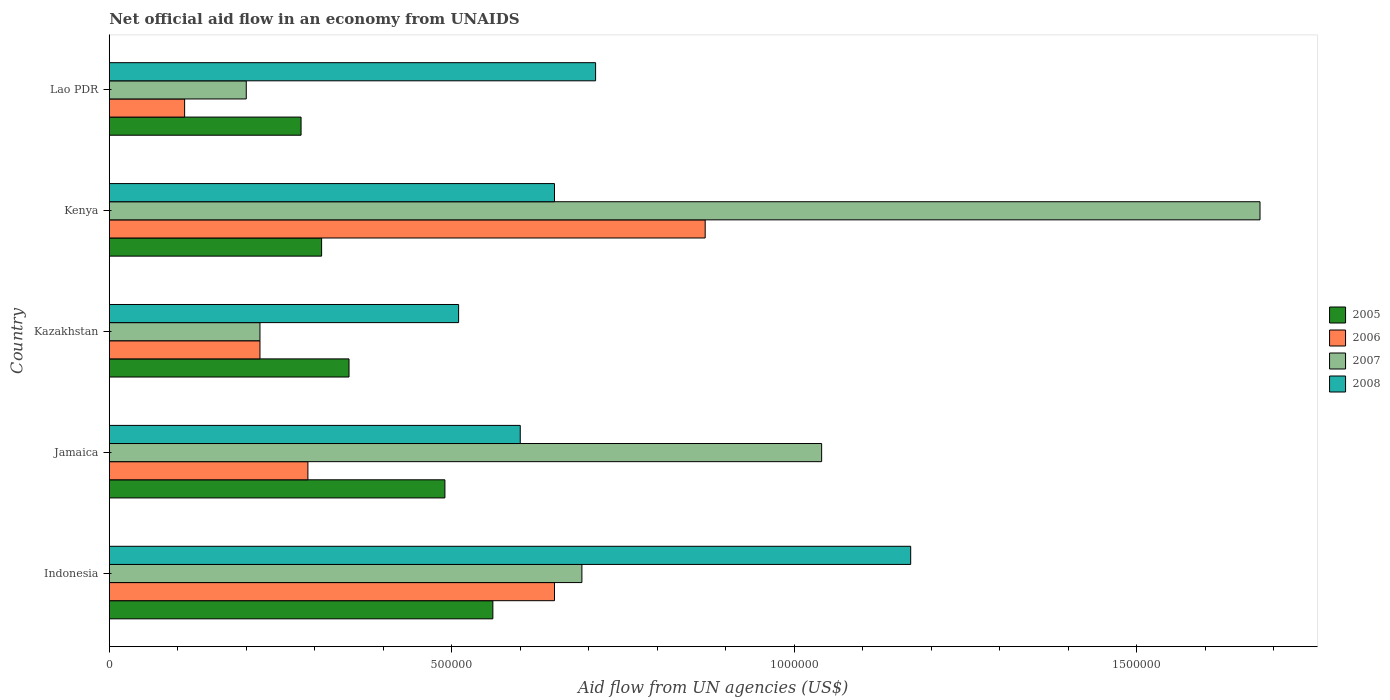How many different coloured bars are there?
Keep it short and to the point. 4. How many groups of bars are there?
Your answer should be very brief. 5. Are the number of bars per tick equal to the number of legend labels?
Provide a succinct answer. Yes. Are the number of bars on each tick of the Y-axis equal?
Offer a very short reply. Yes. How many bars are there on the 2nd tick from the top?
Give a very brief answer. 4. How many bars are there on the 4th tick from the bottom?
Give a very brief answer. 4. What is the label of the 2nd group of bars from the top?
Your answer should be very brief. Kenya. Across all countries, what is the maximum net official aid flow in 2008?
Offer a very short reply. 1.17e+06. In which country was the net official aid flow in 2006 maximum?
Provide a succinct answer. Kenya. In which country was the net official aid flow in 2007 minimum?
Offer a terse response. Lao PDR. What is the total net official aid flow in 2005 in the graph?
Your answer should be compact. 1.99e+06. What is the difference between the net official aid flow in 2006 in Indonesia and that in Jamaica?
Your answer should be very brief. 3.60e+05. What is the difference between the net official aid flow in 2008 in Lao PDR and the net official aid flow in 2006 in Kazakhstan?
Your answer should be compact. 4.90e+05. What is the average net official aid flow in 2006 per country?
Make the answer very short. 4.28e+05. What is the difference between the net official aid flow in 2007 and net official aid flow in 2008 in Kenya?
Offer a terse response. 1.03e+06. In how many countries, is the net official aid flow in 2005 greater than 1200000 US$?
Offer a very short reply. 0. What is the ratio of the net official aid flow in 2008 in Jamaica to that in Kenya?
Your answer should be very brief. 0.92. Is the net official aid flow in 2005 in Indonesia less than that in Kenya?
Your response must be concise. No. What is the difference between the highest and the second highest net official aid flow in 2008?
Make the answer very short. 4.60e+05. Is the sum of the net official aid flow in 2007 in Jamaica and Kenya greater than the maximum net official aid flow in 2005 across all countries?
Provide a succinct answer. Yes. How many bars are there?
Your answer should be compact. 20. How many countries are there in the graph?
Keep it short and to the point. 5. What is the difference between two consecutive major ticks on the X-axis?
Offer a terse response. 5.00e+05. Does the graph contain any zero values?
Your answer should be compact. No. Does the graph contain grids?
Give a very brief answer. No. How many legend labels are there?
Provide a short and direct response. 4. What is the title of the graph?
Provide a succinct answer. Net official aid flow in an economy from UNAIDS. What is the label or title of the X-axis?
Offer a very short reply. Aid flow from UN agencies (US$). What is the label or title of the Y-axis?
Your answer should be very brief. Country. What is the Aid flow from UN agencies (US$) in 2005 in Indonesia?
Offer a terse response. 5.60e+05. What is the Aid flow from UN agencies (US$) of 2006 in Indonesia?
Provide a short and direct response. 6.50e+05. What is the Aid flow from UN agencies (US$) in 2007 in Indonesia?
Provide a succinct answer. 6.90e+05. What is the Aid flow from UN agencies (US$) of 2008 in Indonesia?
Give a very brief answer. 1.17e+06. What is the Aid flow from UN agencies (US$) in 2006 in Jamaica?
Ensure brevity in your answer.  2.90e+05. What is the Aid flow from UN agencies (US$) of 2007 in Jamaica?
Make the answer very short. 1.04e+06. What is the Aid flow from UN agencies (US$) in 2005 in Kazakhstan?
Keep it short and to the point. 3.50e+05. What is the Aid flow from UN agencies (US$) of 2006 in Kazakhstan?
Give a very brief answer. 2.20e+05. What is the Aid flow from UN agencies (US$) of 2007 in Kazakhstan?
Your response must be concise. 2.20e+05. What is the Aid flow from UN agencies (US$) in 2008 in Kazakhstan?
Give a very brief answer. 5.10e+05. What is the Aid flow from UN agencies (US$) of 2006 in Kenya?
Provide a short and direct response. 8.70e+05. What is the Aid flow from UN agencies (US$) in 2007 in Kenya?
Give a very brief answer. 1.68e+06. What is the Aid flow from UN agencies (US$) of 2008 in Kenya?
Provide a succinct answer. 6.50e+05. What is the Aid flow from UN agencies (US$) of 2006 in Lao PDR?
Make the answer very short. 1.10e+05. What is the Aid flow from UN agencies (US$) in 2008 in Lao PDR?
Offer a terse response. 7.10e+05. Across all countries, what is the maximum Aid flow from UN agencies (US$) in 2005?
Keep it short and to the point. 5.60e+05. Across all countries, what is the maximum Aid flow from UN agencies (US$) in 2006?
Offer a terse response. 8.70e+05. Across all countries, what is the maximum Aid flow from UN agencies (US$) in 2007?
Your answer should be compact. 1.68e+06. Across all countries, what is the maximum Aid flow from UN agencies (US$) of 2008?
Offer a terse response. 1.17e+06. Across all countries, what is the minimum Aid flow from UN agencies (US$) in 2005?
Keep it short and to the point. 2.80e+05. Across all countries, what is the minimum Aid flow from UN agencies (US$) of 2007?
Make the answer very short. 2.00e+05. Across all countries, what is the minimum Aid flow from UN agencies (US$) of 2008?
Your answer should be very brief. 5.10e+05. What is the total Aid flow from UN agencies (US$) of 2005 in the graph?
Offer a terse response. 1.99e+06. What is the total Aid flow from UN agencies (US$) in 2006 in the graph?
Offer a very short reply. 2.14e+06. What is the total Aid flow from UN agencies (US$) in 2007 in the graph?
Your answer should be very brief. 3.83e+06. What is the total Aid flow from UN agencies (US$) of 2008 in the graph?
Offer a terse response. 3.64e+06. What is the difference between the Aid flow from UN agencies (US$) of 2007 in Indonesia and that in Jamaica?
Keep it short and to the point. -3.50e+05. What is the difference between the Aid flow from UN agencies (US$) of 2008 in Indonesia and that in Jamaica?
Your answer should be very brief. 5.70e+05. What is the difference between the Aid flow from UN agencies (US$) of 2005 in Indonesia and that in Kazakhstan?
Offer a terse response. 2.10e+05. What is the difference between the Aid flow from UN agencies (US$) in 2007 in Indonesia and that in Kazakhstan?
Provide a succinct answer. 4.70e+05. What is the difference between the Aid flow from UN agencies (US$) of 2008 in Indonesia and that in Kazakhstan?
Give a very brief answer. 6.60e+05. What is the difference between the Aid flow from UN agencies (US$) in 2007 in Indonesia and that in Kenya?
Your response must be concise. -9.90e+05. What is the difference between the Aid flow from UN agencies (US$) in 2008 in Indonesia and that in Kenya?
Ensure brevity in your answer.  5.20e+05. What is the difference between the Aid flow from UN agencies (US$) in 2006 in Indonesia and that in Lao PDR?
Ensure brevity in your answer.  5.40e+05. What is the difference between the Aid flow from UN agencies (US$) in 2005 in Jamaica and that in Kazakhstan?
Make the answer very short. 1.40e+05. What is the difference between the Aid flow from UN agencies (US$) in 2006 in Jamaica and that in Kazakhstan?
Your answer should be very brief. 7.00e+04. What is the difference between the Aid flow from UN agencies (US$) of 2007 in Jamaica and that in Kazakhstan?
Your answer should be compact. 8.20e+05. What is the difference between the Aid flow from UN agencies (US$) of 2008 in Jamaica and that in Kazakhstan?
Your answer should be very brief. 9.00e+04. What is the difference between the Aid flow from UN agencies (US$) of 2006 in Jamaica and that in Kenya?
Make the answer very short. -5.80e+05. What is the difference between the Aid flow from UN agencies (US$) of 2007 in Jamaica and that in Kenya?
Keep it short and to the point. -6.40e+05. What is the difference between the Aid flow from UN agencies (US$) in 2008 in Jamaica and that in Kenya?
Provide a succinct answer. -5.00e+04. What is the difference between the Aid flow from UN agencies (US$) in 2005 in Jamaica and that in Lao PDR?
Keep it short and to the point. 2.10e+05. What is the difference between the Aid flow from UN agencies (US$) in 2007 in Jamaica and that in Lao PDR?
Your answer should be very brief. 8.40e+05. What is the difference between the Aid flow from UN agencies (US$) in 2008 in Jamaica and that in Lao PDR?
Your answer should be compact. -1.10e+05. What is the difference between the Aid flow from UN agencies (US$) of 2005 in Kazakhstan and that in Kenya?
Make the answer very short. 4.00e+04. What is the difference between the Aid flow from UN agencies (US$) of 2006 in Kazakhstan and that in Kenya?
Keep it short and to the point. -6.50e+05. What is the difference between the Aid flow from UN agencies (US$) in 2007 in Kazakhstan and that in Kenya?
Give a very brief answer. -1.46e+06. What is the difference between the Aid flow from UN agencies (US$) in 2006 in Kazakhstan and that in Lao PDR?
Provide a succinct answer. 1.10e+05. What is the difference between the Aid flow from UN agencies (US$) of 2007 in Kazakhstan and that in Lao PDR?
Ensure brevity in your answer.  2.00e+04. What is the difference between the Aid flow from UN agencies (US$) of 2008 in Kazakhstan and that in Lao PDR?
Provide a short and direct response. -2.00e+05. What is the difference between the Aid flow from UN agencies (US$) of 2006 in Kenya and that in Lao PDR?
Your answer should be compact. 7.60e+05. What is the difference between the Aid flow from UN agencies (US$) in 2007 in Kenya and that in Lao PDR?
Provide a succinct answer. 1.48e+06. What is the difference between the Aid flow from UN agencies (US$) of 2008 in Kenya and that in Lao PDR?
Ensure brevity in your answer.  -6.00e+04. What is the difference between the Aid flow from UN agencies (US$) in 2005 in Indonesia and the Aid flow from UN agencies (US$) in 2006 in Jamaica?
Your answer should be very brief. 2.70e+05. What is the difference between the Aid flow from UN agencies (US$) in 2005 in Indonesia and the Aid flow from UN agencies (US$) in 2007 in Jamaica?
Your response must be concise. -4.80e+05. What is the difference between the Aid flow from UN agencies (US$) in 2005 in Indonesia and the Aid flow from UN agencies (US$) in 2008 in Jamaica?
Offer a terse response. -4.00e+04. What is the difference between the Aid flow from UN agencies (US$) of 2006 in Indonesia and the Aid flow from UN agencies (US$) of 2007 in Jamaica?
Offer a terse response. -3.90e+05. What is the difference between the Aid flow from UN agencies (US$) of 2006 in Indonesia and the Aid flow from UN agencies (US$) of 2008 in Jamaica?
Your response must be concise. 5.00e+04. What is the difference between the Aid flow from UN agencies (US$) of 2005 in Indonesia and the Aid flow from UN agencies (US$) of 2006 in Kazakhstan?
Give a very brief answer. 3.40e+05. What is the difference between the Aid flow from UN agencies (US$) in 2005 in Indonesia and the Aid flow from UN agencies (US$) in 2007 in Kazakhstan?
Offer a very short reply. 3.40e+05. What is the difference between the Aid flow from UN agencies (US$) of 2005 in Indonesia and the Aid flow from UN agencies (US$) of 2008 in Kazakhstan?
Your response must be concise. 5.00e+04. What is the difference between the Aid flow from UN agencies (US$) of 2006 in Indonesia and the Aid flow from UN agencies (US$) of 2007 in Kazakhstan?
Make the answer very short. 4.30e+05. What is the difference between the Aid flow from UN agencies (US$) in 2006 in Indonesia and the Aid flow from UN agencies (US$) in 2008 in Kazakhstan?
Provide a short and direct response. 1.40e+05. What is the difference between the Aid flow from UN agencies (US$) of 2007 in Indonesia and the Aid flow from UN agencies (US$) of 2008 in Kazakhstan?
Make the answer very short. 1.80e+05. What is the difference between the Aid flow from UN agencies (US$) in 2005 in Indonesia and the Aid flow from UN agencies (US$) in 2006 in Kenya?
Provide a short and direct response. -3.10e+05. What is the difference between the Aid flow from UN agencies (US$) of 2005 in Indonesia and the Aid flow from UN agencies (US$) of 2007 in Kenya?
Make the answer very short. -1.12e+06. What is the difference between the Aid flow from UN agencies (US$) in 2005 in Indonesia and the Aid flow from UN agencies (US$) in 2008 in Kenya?
Provide a short and direct response. -9.00e+04. What is the difference between the Aid flow from UN agencies (US$) in 2006 in Indonesia and the Aid flow from UN agencies (US$) in 2007 in Kenya?
Offer a terse response. -1.03e+06. What is the difference between the Aid flow from UN agencies (US$) in 2006 in Indonesia and the Aid flow from UN agencies (US$) in 2008 in Kenya?
Your answer should be very brief. 0. What is the difference between the Aid flow from UN agencies (US$) in 2007 in Indonesia and the Aid flow from UN agencies (US$) in 2008 in Kenya?
Ensure brevity in your answer.  4.00e+04. What is the difference between the Aid flow from UN agencies (US$) of 2005 in Indonesia and the Aid flow from UN agencies (US$) of 2006 in Lao PDR?
Ensure brevity in your answer.  4.50e+05. What is the difference between the Aid flow from UN agencies (US$) of 2005 in Indonesia and the Aid flow from UN agencies (US$) of 2008 in Lao PDR?
Make the answer very short. -1.50e+05. What is the difference between the Aid flow from UN agencies (US$) of 2006 in Jamaica and the Aid flow from UN agencies (US$) of 2007 in Kazakhstan?
Give a very brief answer. 7.00e+04. What is the difference between the Aid flow from UN agencies (US$) in 2007 in Jamaica and the Aid flow from UN agencies (US$) in 2008 in Kazakhstan?
Offer a very short reply. 5.30e+05. What is the difference between the Aid flow from UN agencies (US$) of 2005 in Jamaica and the Aid flow from UN agencies (US$) of 2006 in Kenya?
Provide a succinct answer. -3.80e+05. What is the difference between the Aid flow from UN agencies (US$) in 2005 in Jamaica and the Aid flow from UN agencies (US$) in 2007 in Kenya?
Keep it short and to the point. -1.19e+06. What is the difference between the Aid flow from UN agencies (US$) of 2006 in Jamaica and the Aid flow from UN agencies (US$) of 2007 in Kenya?
Provide a succinct answer. -1.39e+06. What is the difference between the Aid flow from UN agencies (US$) in 2006 in Jamaica and the Aid flow from UN agencies (US$) in 2008 in Kenya?
Your answer should be very brief. -3.60e+05. What is the difference between the Aid flow from UN agencies (US$) of 2007 in Jamaica and the Aid flow from UN agencies (US$) of 2008 in Kenya?
Offer a terse response. 3.90e+05. What is the difference between the Aid flow from UN agencies (US$) in 2005 in Jamaica and the Aid flow from UN agencies (US$) in 2006 in Lao PDR?
Your response must be concise. 3.80e+05. What is the difference between the Aid flow from UN agencies (US$) of 2005 in Jamaica and the Aid flow from UN agencies (US$) of 2007 in Lao PDR?
Keep it short and to the point. 2.90e+05. What is the difference between the Aid flow from UN agencies (US$) in 2006 in Jamaica and the Aid flow from UN agencies (US$) in 2008 in Lao PDR?
Your response must be concise. -4.20e+05. What is the difference between the Aid flow from UN agencies (US$) of 2005 in Kazakhstan and the Aid flow from UN agencies (US$) of 2006 in Kenya?
Make the answer very short. -5.20e+05. What is the difference between the Aid flow from UN agencies (US$) of 2005 in Kazakhstan and the Aid flow from UN agencies (US$) of 2007 in Kenya?
Give a very brief answer. -1.33e+06. What is the difference between the Aid flow from UN agencies (US$) of 2006 in Kazakhstan and the Aid flow from UN agencies (US$) of 2007 in Kenya?
Ensure brevity in your answer.  -1.46e+06. What is the difference between the Aid flow from UN agencies (US$) in 2006 in Kazakhstan and the Aid flow from UN agencies (US$) in 2008 in Kenya?
Your response must be concise. -4.30e+05. What is the difference between the Aid flow from UN agencies (US$) in 2007 in Kazakhstan and the Aid flow from UN agencies (US$) in 2008 in Kenya?
Give a very brief answer. -4.30e+05. What is the difference between the Aid flow from UN agencies (US$) of 2005 in Kazakhstan and the Aid flow from UN agencies (US$) of 2007 in Lao PDR?
Your response must be concise. 1.50e+05. What is the difference between the Aid flow from UN agencies (US$) in 2005 in Kazakhstan and the Aid flow from UN agencies (US$) in 2008 in Lao PDR?
Your response must be concise. -3.60e+05. What is the difference between the Aid flow from UN agencies (US$) of 2006 in Kazakhstan and the Aid flow from UN agencies (US$) of 2008 in Lao PDR?
Ensure brevity in your answer.  -4.90e+05. What is the difference between the Aid flow from UN agencies (US$) in 2007 in Kazakhstan and the Aid flow from UN agencies (US$) in 2008 in Lao PDR?
Offer a very short reply. -4.90e+05. What is the difference between the Aid flow from UN agencies (US$) of 2005 in Kenya and the Aid flow from UN agencies (US$) of 2007 in Lao PDR?
Provide a short and direct response. 1.10e+05. What is the difference between the Aid flow from UN agencies (US$) in 2005 in Kenya and the Aid flow from UN agencies (US$) in 2008 in Lao PDR?
Keep it short and to the point. -4.00e+05. What is the difference between the Aid flow from UN agencies (US$) of 2006 in Kenya and the Aid flow from UN agencies (US$) of 2007 in Lao PDR?
Offer a very short reply. 6.70e+05. What is the difference between the Aid flow from UN agencies (US$) of 2006 in Kenya and the Aid flow from UN agencies (US$) of 2008 in Lao PDR?
Offer a very short reply. 1.60e+05. What is the difference between the Aid flow from UN agencies (US$) in 2007 in Kenya and the Aid flow from UN agencies (US$) in 2008 in Lao PDR?
Your response must be concise. 9.70e+05. What is the average Aid flow from UN agencies (US$) in 2005 per country?
Make the answer very short. 3.98e+05. What is the average Aid flow from UN agencies (US$) of 2006 per country?
Offer a terse response. 4.28e+05. What is the average Aid flow from UN agencies (US$) in 2007 per country?
Make the answer very short. 7.66e+05. What is the average Aid flow from UN agencies (US$) of 2008 per country?
Offer a very short reply. 7.28e+05. What is the difference between the Aid flow from UN agencies (US$) of 2005 and Aid flow from UN agencies (US$) of 2008 in Indonesia?
Ensure brevity in your answer.  -6.10e+05. What is the difference between the Aid flow from UN agencies (US$) of 2006 and Aid flow from UN agencies (US$) of 2007 in Indonesia?
Provide a succinct answer. -4.00e+04. What is the difference between the Aid flow from UN agencies (US$) of 2006 and Aid flow from UN agencies (US$) of 2008 in Indonesia?
Offer a terse response. -5.20e+05. What is the difference between the Aid flow from UN agencies (US$) of 2007 and Aid flow from UN agencies (US$) of 2008 in Indonesia?
Your answer should be compact. -4.80e+05. What is the difference between the Aid flow from UN agencies (US$) in 2005 and Aid flow from UN agencies (US$) in 2007 in Jamaica?
Your answer should be compact. -5.50e+05. What is the difference between the Aid flow from UN agencies (US$) in 2006 and Aid flow from UN agencies (US$) in 2007 in Jamaica?
Give a very brief answer. -7.50e+05. What is the difference between the Aid flow from UN agencies (US$) of 2006 and Aid flow from UN agencies (US$) of 2008 in Jamaica?
Give a very brief answer. -3.10e+05. What is the difference between the Aid flow from UN agencies (US$) in 2005 and Aid flow from UN agencies (US$) in 2007 in Kazakhstan?
Your response must be concise. 1.30e+05. What is the difference between the Aid flow from UN agencies (US$) in 2005 and Aid flow from UN agencies (US$) in 2008 in Kazakhstan?
Your response must be concise. -1.60e+05. What is the difference between the Aid flow from UN agencies (US$) of 2007 and Aid flow from UN agencies (US$) of 2008 in Kazakhstan?
Your response must be concise. -2.90e+05. What is the difference between the Aid flow from UN agencies (US$) of 2005 and Aid flow from UN agencies (US$) of 2006 in Kenya?
Make the answer very short. -5.60e+05. What is the difference between the Aid flow from UN agencies (US$) in 2005 and Aid flow from UN agencies (US$) in 2007 in Kenya?
Ensure brevity in your answer.  -1.37e+06. What is the difference between the Aid flow from UN agencies (US$) of 2005 and Aid flow from UN agencies (US$) of 2008 in Kenya?
Your answer should be compact. -3.40e+05. What is the difference between the Aid flow from UN agencies (US$) in 2006 and Aid flow from UN agencies (US$) in 2007 in Kenya?
Keep it short and to the point. -8.10e+05. What is the difference between the Aid flow from UN agencies (US$) of 2007 and Aid flow from UN agencies (US$) of 2008 in Kenya?
Ensure brevity in your answer.  1.03e+06. What is the difference between the Aid flow from UN agencies (US$) in 2005 and Aid flow from UN agencies (US$) in 2006 in Lao PDR?
Make the answer very short. 1.70e+05. What is the difference between the Aid flow from UN agencies (US$) of 2005 and Aid flow from UN agencies (US$) of 2007 in Lao PDR?
Your answer should be very brief. 8.00e+04. What is the difference between the Aid flow from UN agencies (US$) of 2005 and Aid flow from UN agencies (US$) of 2008 in Lao PDR?
Provide a succinct answer. -4.30e+05. What is the difference between the Aid flow from UN agencies (US$) of 2006 and Aid flow from UN agencies (US$) of 2008 in Lao PDR?
Your answer should be compact. -6.00e+05. What is the difference between the Aid flow from UN agencies (US$) in 2007 and Aid flow from UN agencies (US$) in 2008 in Lao PDR?
Your response must be concise. -5.10e+05. What is the ratio of the Aid flow from UN agencies (US$) of 2005 in Indonesia to that in Jamaica?
Provide a succinct answer. 1.14. What is the ratio of the Aid flow from UN agencies (US$) of 2006 in Indonesia to that in Jamaica?
Give a very brief answer. 2.24. What is the ratio of the Aid flow from UN agencies (US$) of 2007 in Indonesia to that in Jamaica?
Provide a short and direct response. 0.66. What is the ratio of the Aid flow from UN agencies (US$) of 2008 in Indonesia to that in Jamaica?
Provide a succinct answer. 1.95. What is the ratio of the Aid flow from UN agencies (US$) of 2005 in Indonesia to that in Kazakhstan?
Make the answer very short. 1.6. What is the ratio of the Aid flow from UN agencies (US$) in 2006 in Indonesia to that in Kazakhstan?
Your response must be concise. 2.95. What is the ratio of the Aid flow from UN agencies (US$) in 2007 in Indonesia to that in Kazakhstan?
Give a very brief answer. 3.14. What is the ratio of the Aid flow from UN agencies (US$) in 2008 in Indonesia to that in Kazakhstan?
Your answer should be compact. 2.29. What is the ratio of the Aid flow from UN agencies (US$) of 2005 in Indonesia to that in Kenya?
Make the answer very short. 1.81. What is the ratio of the Aid flow from UN agencies (US$) of 2006 in Indonesia to that in Kenya?
Offer a very short reply. 0.75. What is the ratio of the Aid flow from UN agencies (US$) of 2007 in Indonesia to that in Kenya?
Provide a succinct answer. 0.41. What is the ratio of the Aid flow from UN agencies (US$) in 2008 in Indonesia to that in Kenya?
Your response must be concise. 1.8. What is the ratio of the Aid flow from UN agencies (US$) of 2006 in Indonesia to that in Lao PDR?
Offer a very short reply. 5.91. What is the ratio of the Aid flow from UN agencies (US$) in 2007 in Indonesia to that in Lao PDR?
Make the answer very short. 3.45. What is the ratio of the Aid flow from UN agencies (US$) in 2008 in Indonesia to that in Lao PDR?
Offer a very short reply. 1.65. What is the ratio of the Aid flow from UN agencies (US$) of 2005 in Jamaica to that in Kazakhstan?
Offer a terse response. 1.4. What is the ratio of the Aid flow from UN agencies (US$) of 2006 in Jamaica to that in Kazakhstan?
Your answer should be very brief. 1.32. What is the ratio of the Aid flow from UN agencies (US$) in 2007 in Jamaica to that in Kazakhstan?
Ensure brevity in your answer.  4.73. What is the ratio of the Aid flow from UN agencies (US$) of 2008 in Jamaica to that in Kazakhstan?
Give a very brief answer. 1.18. What is the ratio of the Aid flow from UN agencies (US$) of 2005 in Jamaica to that in Kenya?
Make the answer very short. 1.58. What is the ratio of the Aid flow from UN agencies (US$) of 2006 in Jamaica to that in Kenya?
Provide a succinct answer. 0.33. What is the ratio of the Aid flow from UN agencies (US$) in 2007 in Jamaica to that in Kenya?
Ensure brevity in your answer.  0.62. What is the ratio of the Aid flow from UN agencies (US$) of 2005 in Jamaica to that in Lao PDR?
Ensure brevity in your answer.  1.75. What is the ratio of the Aid flow from UN agencies (US$) of 2006 in Jamaica to that in Lao PDR?
Your answer should be compact. 2.64. What is the ratio of the Aid flow from UN agencies (US$) in 2008 in Jamaica to that in Lao PDR?
Provide a short and direct response. 0.85. What is the ratio of the Aid flow from UN agencies (US$) in 2005 in Kazakhstan to that in Kenya?
Ensure brevity in your answer.  1.13. What is the ratio of the Aid flow from UN agencies (US$) in 2006 in Kazakhstan to that in Kenya?
Keep it short and to the point. 0.25. What is the ratio of the Aid flow from UN agencies (US$) in 2007 in Kazakhstan to that in Kenya?
Make the answer very short. 0.13. What is the ratio of the Aid flow from UN agencies (US$) of 2008 in Kazakhstan to that in Kenya?
Your response must be concise. 0.78. What is the ratio of the Aid flow from UN agencies (US$) of 2006 in Kazakhstan to that in Lao PDR?
Your answer should be very brief. 2. What is the ratio of the Aid flow from UN agencies (US$) of 2008 in Kazakhstan to that in Lao PDR?
Provide a short and direct response. 0.72. What is the ratio of the Aid flow from UN agencies (US$) in 2005 in Kenya to that in Lao PDR?
Ensure brevity in your answer.  1.11. What is the ratio of the Aid flow from UN agencies (US$) in 2006 in Kenya to that in Lao PDR?
Offer a terse response. 7.91. What is the ratio of the Aid flow from UN agencies (US$) of 2008 in Kenya to that in Lao PDR?
Offer a very short reply. 0.92. What is the difference between the highest and the second highest Aid flow from UN agencies (US$) of 2005?
Offer a terse response. 7.00e+04. What is the difference between the highest and the second highest Aid flow from UN agencies (US$) of 2007?
Provide a succinct answer. 6.40e+05. What is the difference between the highest and the second highest Aid flow from UN agencies (US$) in 2008?
Make the answer very short. 4.60e+05. What is the difference between the highest and the lowest Aid flow from UN agencies (US$) of 2005?
Make the answer very short. 2.80e+05. What is the difference between the highest and the lowest Aid flow from UN agencies (US$) of 2006?
Your answer should be compact. 7.60e+05. What is the difference between the highest and the lowest Aid flow from UN agencies (US$) of 2007?
Your answer should be very brief. 1.48e+06. 